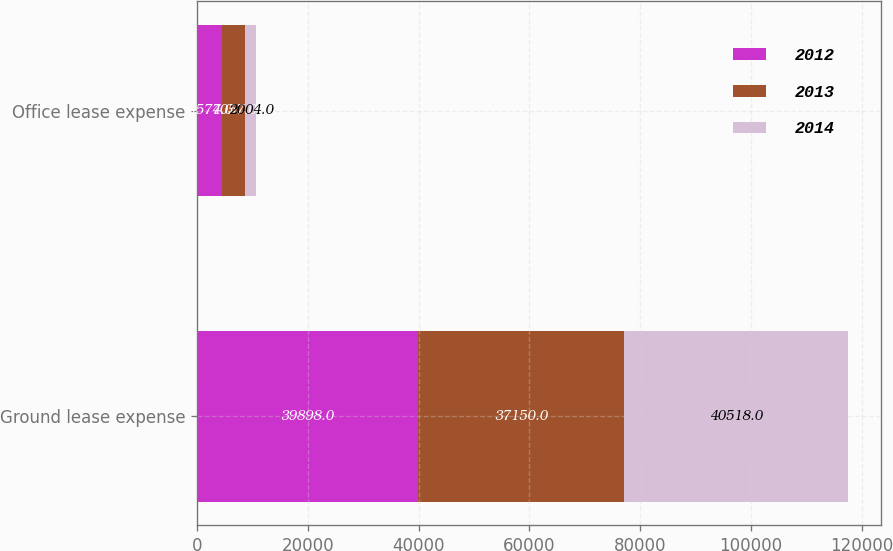<chart> <loc_0><loc_0><loc_500><loc_500><stacked_bar_chart><ecel><fcel>Ground lease expense<fcel>Office lease expense<nl><fcel>2012<fcel>39898<fcel>4577<nl><fcel>2013<fcel>37150<fcel>4057<nl><fcel>2014<fcel>40518<fcel>2004<nl></chart> 